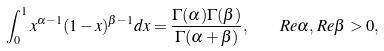Convert formula to latex. <formula><loc_0><loc_0><loc_500><loc_500>\int _ { 0 } ^ { 1 } x ^ { \alpha - 1 } ( 1 - x ) ^ { \beta - 1 } d x = \frac { \Gamma ( \alpha ) \Gamma ( \beta ) } { \Gamma ( \alpha + \beta ) } , \quad R e \alpha , \, R e \beta > 0 ,</formula> 